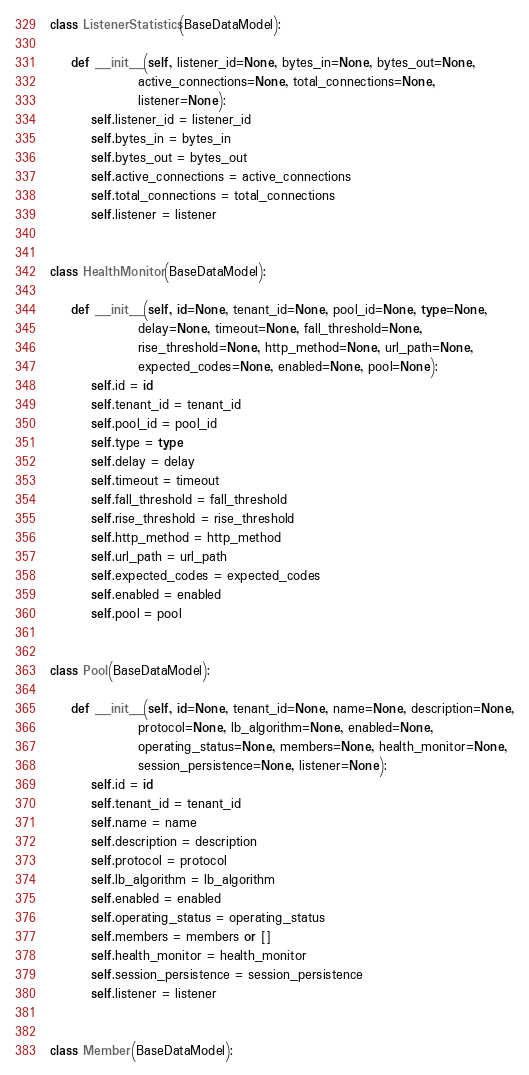<code> <loc_0><loc_0><loc_500><loc_500><_Python_>class ListenerStatistics(BaseDataModel):

    def __init__(self, listener_id=None, bytes_in=None, bytes_out=None,
                 active_connections=None, total_connections=None,
                 listener=None):
        self.listener_id = listener_id
        self.bytes_in = bytes_in
        self.bytes_out = bytes_out
        self.active_connections = active_connections
        self.total_connections = total_connections
        self.listener = listener


class HealthMonitor(BaseDataModel):

    def __init__(self, id=None, tenant_id=None, pool_id=None, type=None,
                 delay=None, timeout=None, fall_threshold=None,
                 rise_threshold=None, http_method=None, url_path=None,
                 expected_codes=None, enabled=None, pool=None):
        self.id = id
        self.tenant_id = tenant_id
        self.pool_id = pool_id
        self.type = type
        self.delay = delay
        self.timeout = timeout
        self.fall_threshold = fall_threshold
        self.rise_threshold = rise_threshold
        self.http_method = http_method
        self.url_path = url_path
        self.expected_codes = expected_codes
        self.enabled = enabled
        self.pool = pool


class Pool(BaseDataModel):

    def __init__(self, id=None, tenant_id=None, name=None, description=None,
                 protocol=None, lb_algorithm=None, enabled=None,
                 operating_status=None, members=None, health_monitor=None,
                 session_persistence=None, listener=None):
        self.id = id
        self.tenant_id = tenant_id
        self.name = name
        self.description = description
        self.protocol = protocol
        self.lb_algorithm = lb_algorithm
        self.enabled = enabled
        self.operating_status = operating_status
        self.members = members or []
        self.health_monitor = health_monitor
        self.session_persistence = session_persistence
        self.listener = listener


class Member(BaseDataModel):
</code> 